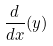<formula> <loc_0><loc_0><loc_500><loc_500>\frac { d } { d x } ( y )</formula> 